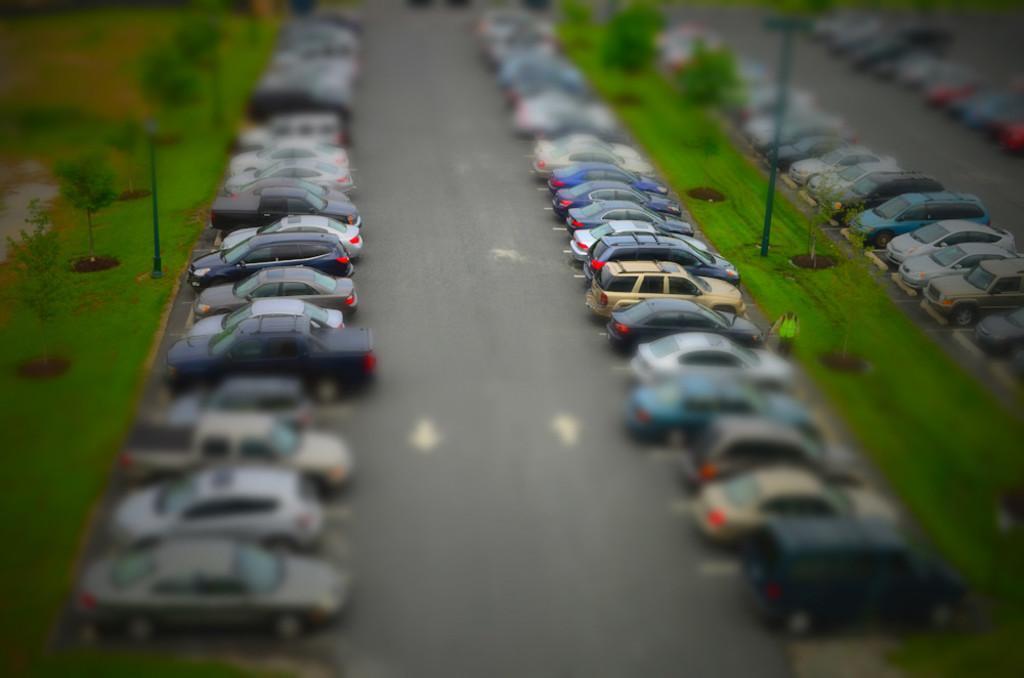How would you summarize this image in a sentence or two? There are cars on the road. Here we can see poles, plants, and grass. Here we can see a person. 